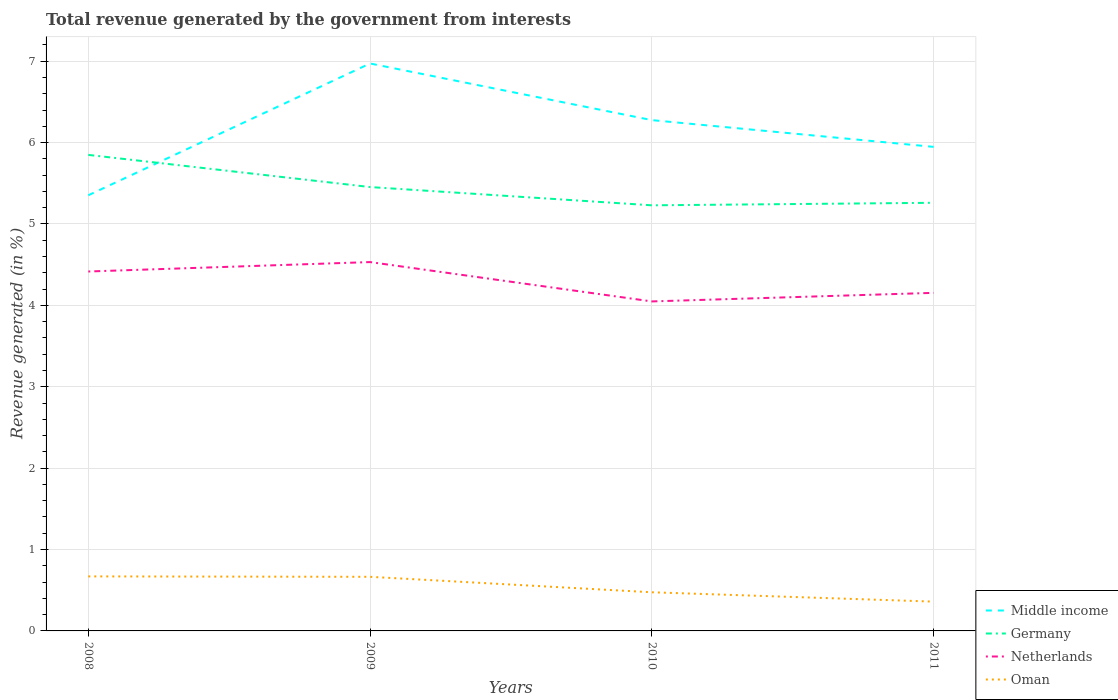How many different coloured lines are there?
Give a very brief answer. 4. Does the line corresponding to Oman intersect with the line corresponding to Germany?
Provide a short and direct response. No. Is the number of lines equal to the number of legend labels?
Provide a succinct answer. Yes. Across all years, what is the maximum total revenue generated in Middle income?
Ensure brevity in your answer.  5.35. What is the total total revenue generated in Middle income in the graph?
Give a very brief answer. -1.62. What is the difference between the highest and the second highest total revenue generated in Germany?
Keep it short and to the point. 0.62. How many lines are there?
Provide a succinct answer. 4. What is the difference between two consecutive major ticks on the Y-axis?
Ensure brevity in your answer.  1. Are the values on the major ticks of Y-axis written in scientific E-notation?
Ensure brevity in your answer.  No. Does the graph contain any zero values?
Offer a terse response. No. Where does the legend appear in the graph?
Your answer should be very brief. Bottom right. How many legend labels are there?
Provide a short and direct response. 4. How are the legend labels stacked?
Your response must be concise. Vertical. What is the title of the graph?
Offer a terse response. Total revenue generated by the government from interests. Does "North America" appear as one of the legend labels in the graph?
Provide a succinct answer. No. What is the label or title of the X-axis?
Offer a very short reply. Years. What is the label or title of the Y-axis?
Provide a short and direct response. Revenue generated (in %). What is the Revenue generated (in %) of Middle income in 2008?
Offer a terse response. 5.35. What is the Revenue generated (in %) in Germany in 2008?
Offer a terse response. 5.85. What is the Revenue generated (in %) in Netherlands in 2008?
Your answer should be very brief. 4.42. What is the Revenue generated (in %) of Oman in 2008?
Your answer should be compact. 0.67. What is the Revenue generated (in %) in Middle income in 2009?
Keep it short and to the point. 6.97. What is the Revenue generated (in %) in Germany in 2009?
Offer a very short reply. 5.45. What is the Revenue generated (in %) of Netherlands in 2009?
Your answer should be compact. 4.53. What is the Revenue generated (in %) of Oman in 2009?
Your answer should be very brief. 0.66. What is the Revenue generated (in %) of Middle income in 2010?
Provide a short and direct response. 6.28. What is the Revenue generated (in %) of Germany in 2010?
Offer a terse response. 5.23. What is the Revenue generated (in %) of Netherlands in 2010?
Make the answer very short. 4.05. What is the Revenue generated (in %) in Oman in 2010?
Offer a very short reply. 0.47. What is the Revenue generated (in %) of Middle income in 2011?
Make the answer very short. 5.95. What is the Revenue generated (in %) of Germany in 2011?
Provide a succinct answer. 5.26. What is the Revenue generated (in %) of Netherlands in 2011?
Offer a very short reply. 4.15. What is the Revenue generated (in %) of Oman in 2011?
Offer a terse response. 0.36. Across all years, what is the maximum Revenue generated (in %) in Middle income?
Provide a short and direct response. 6.97. Across all years, what is the maximum Revenue generated (in %) of Germany?
Ensure brevity in your answer.  5.85. Across all years, what is the maximum Revenue generated (in %) of Netherlands?
Your answer should be compact. 4.53. Across all years, what is the maximum Revenue generated (in %) in Oman?
Offer a terse response. 0.67. Across all years, what is the minimum Revenue generated (in %) in Middle income?
Provide a succinct answer. 5.35. Across all years, what is the minimum Revenue generated (in %) in Germany?
Make the answer very short. 5.23. Across all years, what is the minimum Revenue generated (in %) in Netherlands?
Your answer should be very brief. 4.05. Across all years, what is the minimum Revenue generated (in %) of Oman?
Ensure brevity in your answer.  0.36. What is the total Revenue generated (in %) in Middle income in the graph?
Provide a short and direct response. 24.55. What is the total Revenue generated (in %) in Germany in the graph?
Ensure brevity in your answer.  21.79. What is the total Revenue generated (in %) in Netherlands in the graph?
Offer a very short reply. 17.15. What is the total Revenue generated (in %) in Oman in the graph?
Offer a very short reply. 2.17. What is the difference between the Revenue generated (in %) of Middle income in 2008 and that in 2009?
Give a very brief answer. -1.62. What is the difference between the Revenue generated (in %) of Germany in 2008 and that in 2009?
Your answer should be compact. 0.4. What is the difference between the Revenue generated (in %) in Netherlands in 2008 and that in 2009?
Ensure brevity in your answer.  -0.12. What is the difference between the Revenue generated (in %) in Oman in 2008 and that in 2009?
Provide a short and direct response. 0.01. What is the difference between the Revenue generated (in %) in Middle income in 2008 and that in 2010?
Ensure brevity in your answer.  -0.92. What is the difference between the Revenue generated (in %) of Germany in 2008 and that in 2010?
Provide a succinct answer. 0.62. What is the difference between the Revenue generated (in %) of Netherlands in 2008 and that in 2010?
Provide a short and direct response. 0.37. What is the difference between the Revenue generated (in %) in Oman in 2008 and that in 2010?
Provide a short and direct response. 0.2. What is the difference between the Revenue generated (in %) of Middle income in 2008 and that in 2011?
Provide a succinct answer. -0.59. What is the difference between the Revenue generated (in %) of Germany in 2008 and that in 2011?
Your answer should be compact. 0.59. What is the difference between the Revenue generated (in %) in Netherlands in 2008 and that in 2011?
Give a very brief answer. 0.26. What is the difference between the Revenue generated (in %) of Oman in 2008 and that in 2011?
Ensure brevity in your answer.  0.31. What is the difference between the Revenue generated (in %) in Middle income in 2009 and that in 2010?
Offer a terse response. 0.7. What is the difference between the Revenue generated (in %) of Germany in 2009 and that in 2010?
Keep it short and to the point. 0.22. What is the difference between the Revenue generated (in %) in Netherlands in 2009 and that in 2010?
Offer a terse response. 0.48. What is the difference between the Revenue generated (in %) of Oman in 2009 and that in 2010?
Provide a short and direct response. 0.19. What is the difference between the Revenue generated (in %) of Middle income in 2009 and that in 2011?
Give a very brief answer. 1.02. What is the difference between the Revenue generated (in %) in Germany in 2009 and that in 2011?
Ensure brevity in your answer.  0.19. What is the difference between the Revenue generated (in %) in Netherlands in 2009 and that in 2011?
Give a very brief answer. 0.38. What is the difference between the Revenue generated (in %) in Oman in 2009 and that in 2011?
Provide a short and direct response. 0.3. What is the difference between the Revenue generated (in %) of Middle income in 2010 and that in 2011?
Offer a terse response. 0.33. What is the difference between the Revenue generated (in %) in Germany in 2010 and that in 2011?
Keep it short and to the point. -0.03. What is the difference between the Revenue generated (in %) in Netherlands in 2010 and that in 2011?
Keep it short and to the point. -0.11. What is the difference between the Revenue generated (in %) of Oman in 2010 and that in 2011?
Ensure brevity in your answer.  0.11. What is the difference between the Revenue generated (in %) of Middle income in 2008 and the Revenue generated (in %) of Germany in 2009?
Offer a terse response. -0.1. What is the difference between the Revenue generated (in %) of Middle income in 2008 and the Revenue generated (in %) of Netherlands in 2009?
Give a very brief answer. 0.82. What is the difference between the Revenue generated (in %) of Middle income in 2008 and the Revenue generated (in %) of Oman in 2009?
Give a very brief answer. 4.69. What is the difference between the Revenue generated (in %) of Germany in 2008 and the Revenue generated (in %) of Netherlands in 2009?
Ensure brevity in your answer.  1.32. What is the difference between the Revenue generated (in %) in Germany in 2008 and the Revenue generated (in %) in Oman in 2009?
Offer a very short reply. 5.18. What is the difference between the Revenue generated (in %) in Netherlands in 2008 and the Revenue generated (in %) in Oman in 2009?
Give a very brief answer. 3.75. What is the difference between the Revenue generated (in %) in Middle income in 2008 and the Revenue generated (in %) in Germany in 2010?
Keep it short and to the point. 0.12. What is the difference between the Revenue generated (in %) of Middle income in 2008 and the Revenue generated (in %) of Netherlands in 2010?
Your response must be concise. 1.3. What is the difference between the Revenue generated (in %) of Middle income in 2008 and the Revenue generated (in %) of Oman in 2010?
Give a very brief answer. 4.88. What is the difference between the Revenue generated (in %) of Germany in 2008 and the Revenue generated (in %) of Netherlands in 2010?
Your response must be concise. 1.8. What is the difference between the Revenue generated (in %) of Germany in 2008 and the Revenue generated (in %) of Oman in 2010?
Give a very brief answer. 5.37. What is the difference between the Revenue generated (in %) in Netherlands in 2008 and the Revenue generated (in %) in Oman in 2010?
Give a very brief answer. 3.94. What is the difference between the Revenue generated (in %) in Middle income in 2008 and the Revenue generated (in %) in Germany in 2011?
Provide a succinct answer. 0.09. What is the difference between the Revenue generated (in %) in Middle income in 2008 and the Revenue generated (in %) in Netherlands in 2011?
Your answer should be compact. 1.2. What is the difference between the Revenue generated (in %) in Middle income in 2008 and the Revenue generated (in %) in Oman in 2011?
Make the answer very short. 4.99. What is the difference between the Revenue generated (in %) of Germany in 2008 and the Revenue generated (in %) of Netherlands in 2011?
Your answer should be very brief. 1.7. What is the difference between the Revenue generated (in %) in Germany in 2008 and the Revenue generated (in %) in Oman in 2011?
Your answer should be compact. 5.49. What is the difference between the Revenue generated (in %) of Netherlands in 2008 and the Revenue generated (in %) of Oman in 2011?
Provide a short and direct response. 4.06. What is the difference between the Revenue generated (in %) in Middle income in 2009 and the Revenue generated (in %) in Germany in 2010?
Your answer should be compact. 1.74. What is the difference between the Revenue generated (in %) in Middle income in 2009 and the Revenue generated (in %) in Netherlands in 2010?
Keep it short and to the point. 2.92. What is the difference between the Revenue generated (in %) in Middle income in 2009 and the Revenue generated (in %) in Oman in 2010?
Your answer should be very brief. 6.5. What is the difference between the Revenue generated (in %) in Germany in 2009 and the Revenue generated (in %) in Netherlands in 2010?
Keep it short and to the point. 1.41. What is the difference between the Revenue generated (in %) in Germany in 2009 and the Revenue generated (in %) in Oman in 2010?
Keep it short and to the point. 4.98. What is the difference between the Revenue generated (in %) of Netherlands in 2009 and the Revenue generated (in %) of Oman in 2010?
Your answer should be compact. 4.06. What is the difference between the Revenue generated (in %) in Middle income in 2009 and the Revenue generated (in %) in Germany in 2011?
Keep it short and to the point. 1.71. What is the difference between the Revenue generated (in %) in Middle income in 2009 and the Revenue generated (in %) in Netherlands in 2011?
Your answer should be very brief. 2.82. What is the difference between the Revenue generated (in %) in Middle income in 2009 and the Revenue generated (in %) in Oman in 2011?
Ensure brevity in your answer.  6.61. What is the difference between the Revenue generated (in %) of Germany in 2009 and the Revenue generated (in %) of Netherlands in 2011?
Your response must be concise. 1.3. What is the difference between the Revenue generated (in %) of Germany in 2009 and the Revenue generated (in %) of Oman in 2011?
Make the answer very short. 5.09. What is the difference between the Revenue generated (in %) of Netherlands in 2009 and the Revenue generated (in %) of Oman in 2011?
Your answer should be very brief. 4.17. What is the difference between the Revenue generated (in %) of Middle income in 2010 and the Revenue generated (in %) of Germany in 2011?
Provide a short and direct response. 1.02. What is the difference between the Revenue generated (in %) in Middle income in 2010 and the Revenue generated (in %) in Netherlands in 2011?
Offer a terse response. 2.12. What is the difference between the Revenue generated (in %) of Middle income in 2010 and the Revenue generated (in %) of Oman in 2011?
Your answer should be compact. 5.92. What is the difference between the Revenue generated (in %) of Germany in 2010 and the Revenue generated (in %) of Netherlands in 2011?
Provide a short and direct response. 1.08. What is the difference between the Revenue generated (in %) in Germany in 2010 and the Revenue generated (in %) in Oman in 2011?
Keep it short and to the point. 4.87. What is the difference between the Revenue generated (in %) of Netherlands in 2010 and the Revenue generated (in %) of Oman in 2011?
Make the answer very short. 3.69. What is the average Revenue generated (in %) of Middle income per year?
Provide a short and direct response. 6.14. What is the average Revenue generated (in %) in Germany per year?
Provide a short and direct response. 5.45. What is the average Revenue generated (in %) of Netherlands per year?
Provide a short and direct response. 4.29. What is the average Revenue generated (in %) in Oman per year?
Keep it short and to the point. 0.54. In the year 2008, what is the difference between the Revenue generated (in %) of Middle income and Revenue generated (in %) of Germany?
Ensure brevity in your answer.  -0.5. In the year 2008, what is the difference between the Revenue generated (in %) of Middle income and Revenue generated (in %) of Netherlands?
Keep it short and to the point. 0.94. In the year 2008, what is the difference between the Revenue generated (in %) in Middle income and Revenue generated (in %) in Oman?
Keep it short and to the point. 4.68. In the year 2008, what is the difference between the Revenue generated (in %) in Germany and Revenue generated (in %) in Netherlands?
Your answer should be very brief. 1.43. In the year 2008, what is the difference between the Revenue generated (in %) in Germany and Revenue generated (in %) in Oman?
Ensure brevity in your answer.  5.18. In the year 2008, what is the difference between the Revenue generated (in %) in Netherlands and Revenue generated (in %) in Oman?
Provide a short and direct response. 3.75. In the year 2009, what is the difference between the Revenue generated (in %) in Middle income and Revenue generated (in %) in Germany?
Your answer should be compact. 1.52. In the year 2009, what is the difference between the Revenue generated (in %) in Middle income and Revenue generated (in %) in Netherlands?
Your response must be concise. 2.44. In the year 2009, what is the difference between the Revenue generated (in %) of Middle income and Revenue generated (in %) of Oman?
Provide a short and direct response. 6.31. In the year 2009, what is the difference between the Revenue generated (in %) of Germany and Revenue generated (in %) of Netherlands?
Ensure brevity in your answer.  0.92. In the year 2009, what is the difference between the Revenue generated (in %) in Germany and Revenue generated (in %) in Oman?
Offer a terse response. 4.79. In the year 2009, what is the difference between the Revenue generated (in %) in Netherlands and Revenue generated (in %) in Oman?
Your answer should be compact. 3.87. In the year 2010, what is the difference between the Revenue generated (in %) of Middle income and Revenue generated (in %) of Germany?
Give a very brief answer. 1.05. In the year 2010, what is the difference between the Revenue generated (in %) in Middle income and Revenue generated (in %) in Netherlands?
Your response must be concise. 2.23. In the year 2010, what is the difference between the Revenue generated (in %) of Middle income and Revenue generated (in %) of Oman?
Provide a short and direct response. 5.8. In the year 2010, what is the difference between the Revenue generated (in %) in Germany and Revenue generated (in %) in Netherlands?
Offer a very short reply. 1.18. In the year 2010, what is the difference between the Revenue generated (in %) in Germany and Revenue generated (in %) in Oman?
Provide a short and direct response. 4.75. In the year 2010, what is the difference between the Revenue generated (in %) in Netherlands and Revenue generated (in %) in Oman?
Your answer should be compact. 3.57. In the year 2011, what is the difference between the Revenue generated (in %) in Middle income and Revenue generated (in %) in Germany?
Your answer should be compact. 0.69. In the year 2011, what is the difference between the Revenue generated (in %) of Middle income and Revenue generated (in %) of Netherlands?
Your answer should be compact. 1.79. In the year 2011, what is the difference between the Revenue generated (in %) of Middle income and Revenue generated (in %) of Oman?
Offer a terse response. 5.59. In the year 2011, what is the difference between the Revenue generated (in %) in Germany and Revenue generated (in %) in Netherlands?
Offer a terse response. 1.11. In the year 2011, what is the difference between the Revenue generated (in %) in Germany and Revenue generated (in %) in Oman?
Provide a succinct answer. 4.9. In the year 2011, what is the difference between the Revenue generated (in %) of Netherlands and Revenue generated (in %) of Oman?
Provide a succinct answer. 3.79. What is the ratio of the Revenue generated (in %) in Middle income in 2008 to that in 2009?
Your answer should be compact. 0.77. What is the ratio of the Revenue generated (in %) of Germany in 2008 to that in 2009?
Your answer should be compact. 1.07. What is the ratio of the Revenue generated (in %) in Netherlands in 2008 to that in 2009?
Your answer should be compact. 0.97. What is the ratio of the Revenue generated (in %) of Oman in 2008 to that in 2009?
Provide a short and direct response. 1.01. What is the ratio of the Revenue generated (in %) in Middle income in 2008 to that in 2010?
Give a very brief answer. 0.85. What is the ratio of the Revenue generated (in %) in Germany in 2008 to that in 2010?
Your answer should be compact. 1.12. What is the ratio of the Revenue generated (in %) of Netherlands in 2008 to that in 2010?
Keep it short and to the point. 1.09. What is the ratio of the Revenue generated (in %) in Oman in 2008 to that in 2010?
Ensure brevity in your answer.  1.41. What is the ratio of the Revenue generated (in %) of Middle income in 2008 to that in 2011?
Ensure brevity in your answer.  0.9. What is the ratio of the Revenue generated (in %) in Germany in 2008 to that in 2011?
Provide a short and direct response. 1.11. What is the ratio of the Revenue generated (in %) of Netherlands in 2008 to that in 2011?
Your answer should be very brief. 1.06. What is the ratio of the Revenue generated (in %) in Oman in 2008 to that in 2011?
Make the answer very short. 1.86. What is the ratio of the Revenue generated (in %) in Middle income in 2009 to that in 2010?
Your answer should be very brief. 1.11. What is the ratio of the Revenue generated (in %) of Germany in 2009 to that in 2010?
Offer a very short reply. 1.04. What is the ratio of the Revenue generated (in %) in Netherlands in 2009 to that in 2010?
Keep it short and to the point. 1.12. What is the ratio of the Revenue generated (in %) in Oman in 2009 to that in 2010?
Offer a terse response. 1.4. What is the ratio of the Revenue generated (in %) of Middle income in 2009 to that in 2011?
Offer a very short reply. 1.17. What is the ratio of the Revenue generated (in %) of Germany in 2009 to that in 2011?
Give a very brief answer. 1.04. What is the ratio of the Revenue generated (in %) in Netherlands in 2009 to that in 2011?
Your response must be concise. 1.09. What is the ratio of the Revenue generated (in %) in Oman in 2009 to that in 2011?
Your answer should be very brief. 1.85. What is the ratio of the Revenue generated (in %) of Middle income in 2010 to that in 2011?
Give a very brief answer. 1.06. What is the ratio of the Revenue generated (in %) of Germany in 2010 to that in 2011?
Give a very brief answer. 0.99. What is the ratio of the Revenue generated (in %) of Netherlands in 2010 to that in 2011?
Your response must be concise. 0.97. What is the ratio of the Revenue generated (in %) in Oman in 2010 to that in 2011?
Offer a terse response. 1.32. What is the difference between the highest and the second highest Revenue generated (in %) in Middle income?
Your response must be concise. 0.7. What is the difference between the highest and the second highest Revenue generated (in %) of Germany?
Offer a very short reply. 0.4. What is the difference between the highest and the second highest Revenue generated (in %) in Netherlands?
Make the answer very short. 0.12. What is the difference between the highest and the second highest Revenue generated (in %) in Oman?
Keep it short and to the point. 0.01. What is the difference between the highest and the lowest Revenue generated (in %) in Middle income?
Ensure brevity in your answer.  1.62. What is the difference between the highest and the lowest Revenue generated (in %) of Germany?
Your response must be concise. 0.62. What is the difference between the highest and the lowest Revenue generated (in %) of Netherlands?
Keep it short and to the point. 0.48. What is the difference between the highest and the lowest Revenue generated (in %) of Oman?
Ensure brevity in your answer.  0.31. 